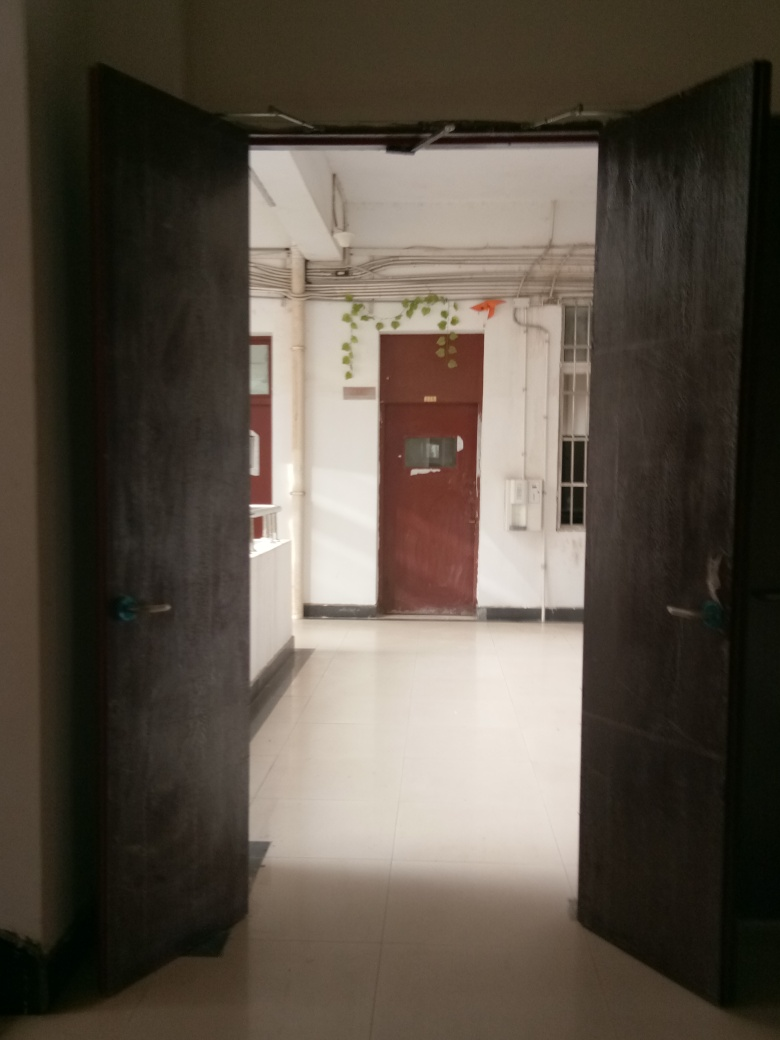What is the main subject of the image?
A. A tree
B. A window
C. A door The main subject of the image is a door, specifically an open dark-colored door that leads into a brightly lit interior space, allowing us to glimpse a part of a building with a visible corridor and other doors. 